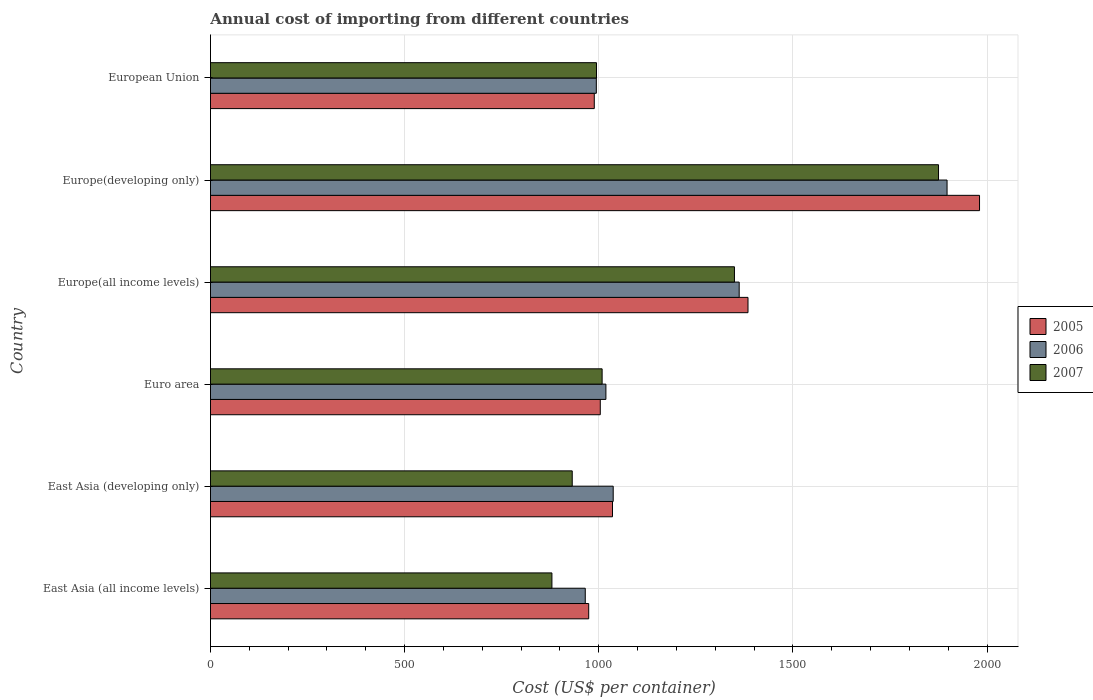Are the number of bars on each tick of the Y-axis equal?
Provide a short and direct response. Yes. How many bars are there on the 1st tick from the top?
Ensure brevity in your answer.  3. What is the label of the 6th group of bars from the top?
Offer a terse response. East Asia (all income levels). What is the total annual cost of importing in 2007 in East Asia (all income levels)?
Provide a succinct answer. 879.32. Across all countries, what is the maximum total annual cost of importing in 2007?
Keep it short and to the point. 1874.94. Across all countries, what is the minimum total annual cost of importing in 2006?
Provide a short and direct response. 965.21. In which country was the total annual cost of importing in 2006 maximum?
Your answer should be compact. Europe(developing only). In which country was the total annual cost of importing in 2007 minimum?
Your answer should be compact. East Asia (all income levels). What is the total total annual cost of importing in 2005 in the graph?
Your answer should be compact. 7366.62. What is the difference between the total annual cost of importing in 2007 in East Asia (developing only) and that in Euro area?
Your answer should be very brief. -77. What is the difference between the total annual cost of importing in 2005 in East Asia (all income levels) and the total annual cost of importing in 2007 in Europe(all income levels)?
Keep it short and to the point. -375.34. What is the average total annual cost of importing in 2006 per country?
Your answer should be compact. 1212.16. What is the difference between the total annual cost of importing in 2007 and total annual cost of importing in 2006 in East Asia (developing only)?
Your answer should be compact. -105.5. In how many countries, is the total annual cost of importing in 2006 greater than 200 US$?
Your response must be concise. 6. What is the ratio of the total annual cost of importing in 2005 in Euro area to that in European Union?
Make the answer very short. 1.02. Is the total annual cost of importing in 2007 in Europe(all income levels) less than that in Europe(developing only)?
Your answer should be compact. Yes. What is the difference between the highest and the second highest total annual cost of importing in 2006?
Your answer should be compact. 535.34. What is the difference between the highest and the lowest total annual cost of importing in 2006?
Make the answer very short. 931.73. Is the sum of the total annual cost of importing in 2006 in East Asia (all income levels) and Euro area greater than the maximum total annual cost of importing in 2007 across all countries?
Offer a very short reply. Yes. What does the 2nd bar from the top in Europe(developing only) represents?
Your response must be concise. 2006. How many bars are there?
Your response must be concise. 18. Does the graph contain any zero values?
Offer a terse response. No. How are the legend labels stacked?
Your response must be concise. Vertical. What is the title of the graph?
Provide a succinct answer. Annual cost of importing from different countries. What is the label or title of the X-axis?
Offer a terse response. Cost (US$ per container). What is the Cost (US$ per container) of 2005 in East Asia (all income levels)?
Ensure brevity in your answer.  974.07. What is the Cost (US$ per container) in 2006 in East Asia (all income levels)?
Offer a terse response. 965.21. What is the Cost (US$ per container) in 2007 in East Asia (all income levels)?
Provide a short and direct response. 879.32. What is the Cost (US$ per container) of 2005 in East Asia (developing only)?
Make the answer very short. 1035.35. What is the Cost (US$ per container) of 2006 in East Asia (developing only)?
Your response must be concise. 1037.15. What is the Cost (US$ per container) in 2007 in East Asia (developing only)?
Keep it short and to the point. 931.65. What is the Cost (US$ per container) of 2005 in Euro area?
Keep it short and to the point. 1003.88. What is the Cost (US$ per container) in 2006 in Euro area?
Offer a terse response. 1018.35. What is the Cost (US$ per container) of 2007 in Euro area?
Ensure brevity in your answer.  1008.65. What is the Cost (US$ per container) of 2005 in Europe(all income levels)?
Your response must be concise. 1384.3. What is the Cost (US$ per container) in 2006 in Europe(all income levels)?
Make the answer very short. 1361.61. What is the Cost (US$ per container) in 2007 in Europe(all income levels)?
Keep it short and to the point. 1349.41. What is the Cost (US$ per container) in 2005 in Europe(developing only)?
Your answer should be very brief. 1980.59. What is the Cost (US$ per container) in 2006 in Europe(developing only)?
Your response must be concise. 1896.94. What is the Cost (US$ per container) of 2007 in Europe(developing only)?
Provide a succinct answer. 1874.94. What is the Cost (US$ per container) in 2005 in European Union?
Provide a short and direct response. 988.44. What is the Cost (US$ per container) in 2006 in European Union?
Provide a succinct answer. 993.69. What is the Cost (US$ per container) of 2007 in European Union?
Offer a very short reply. 994.12. Across all countries, what is the maximum Cost (US$ per container) in 2005?
Your answer should be compact. 1980.59. Across all countries, what is the maximum Cost (US$ per container) in 2006?
Give a very brief answer. 1896.94. Across all countries, what is the maximum Cost (US$ per container) in 2007?
Your response must be concise. 1874.94. Across all countries, what is the minimum Cost (US$ per container) of 2005?
Your response must be concise. 974.07. Across all countries, what is the minimum Cost (US$ per container) in 2006?
Provide a succinct answer. 965.21. Across all countries, what is the minimum Cost (US$ per container) of 2007?
Give a very brief answer. 879.32. What is the total Cost (US$ per container) of 2005 in the graph?
Give a very brief answer. 7366.62. What is the total Cost (US$ per container) in 2006 in the graph?
Give a very brief answer. 7272.96. What is the total Cost (US$ per container) of 2007 in the graph?
Your answer should be very brief. 7038.09. What is the difference between the Cost (US$ per container) of 2005 in East Asia (all income levels) and that in East Asia (developing only)?
Your answer should be very brief. -61.28. What is the difference between the Cost (US$ per container) in 2006 in East Asia (all income levels) and that in East Asia (developing only)?
Your answer should be very brief. -71.94. What is the difference between the Cost (US$ per container) in 2007 in East Asia (all income levels) and that in East Asia (developing only)?
Keep it short and to the point. -52.33. What is the difference between the Cost (US$ per container) in 2005 in East Asia (all income levels) and that in Euro area?
Offer a very short reply. -29.8. What is the difference between the Cost (US$ per container) of 2006 in East Asia (all income levels) and that in Euro area?
Ensure brevity in your answer.  -53.14. What is the difference between the Cost (US$ per container) in 2007 in East Asia (all income levels) and that in Euro area?
Provide a short and direct response. -129.33. What is the difference between the Cost (US$ per container) of 2005 in East Asia (all income levels) and that in Europe(all income levels)?
Your response must be concise. -410.22. What is the difference between the Cost (US$ per container) in 2006 in East Asia (all income levels) and that in Europe(all income levels)?
Your answer should be compact. -396.39. What is the difference between the Cost (US$ per container) of 2007 in East Asia (all income levels) and that in Europe(all income levels)?
Offer a very short reply. -470.09. What is the difference between the Cost (US$ per container) of 2005 in East Asia (all income levels) and that in Europe(developing only)?
Your answer should be very brief. -1006.51. What is the difference between the Cost (US$ per container) of 2006 in East Asia (all income levels) and that in Europe(developing only)?
Your answer should be very brief. -931.73. What is the difference between the Cost (US$ per container) of 2007 in East Asia (all income levels) and that in Europe(developing only)?
Give a very brief answer. -995.62. What is the difference between the Cost (US$ per container) in 2005 in East Asia (all income levels) and that in European Union?
Your answer should be very brief. -14.37. What is the difference between the Cost (US$ per container) in 2006 in East Asia (all income levels) and that in European Union?
Offer a very short reply. -28.48. What is the difference between the Cost (US$ per container) of 2007 in East Asia (all income levels) and that in European Union?
Give a very brief answer. -114.79. What is the difference between the Cost (US$ per container) of 2005 in East Asia (developing only) and that in Euro area?
Provide a succinct answer. 31.48. What is the difference between the Cost (US$ per container) of 2006 in East Asia (developing only) and that in Euro area?
Offer a very short reply. 18.8. What is the difference between the Cost (US$ per container) of 2007 in East Asia (developing only) and that in Euro area?
Ensure brevity in your answer.  -77. What is the difference between the Cost (US$ per container) in 2005 in East Asia (developing only) and that in Europe(all income levels)?
Provide a short and direct response. -348.95. What is the difference between the Cost (US$ per container) in 2006 in East Asia (developing only) and that in Europe(all income levels)?
Give a very brief answer. -324.46. What is the difference between the Cost (US$ per container) of 2007 in East Asia (developing only) and that in Europe(all income levels)?
Make the answer very short. -417.76. What is the difference between the Cost (US$ per container) of 2005 in East Asia (developing only) and that in Europe(developing only)?
Your answer should be compact. -945.24. What is the difference between the Cost (US$ per container) of 2006 in East Asia (developing only) and that in Europe(developing only)?
Make the answer very short. -859.79. What is the difference between the Cost (US$ per container) of 2007 in East Asia (developing only) and that in Europe(developing only)?
Make the answer very short. -943.29. What is the difference between the Cost (US$ per container) of 2005 in East Asia (developing only) and that in European Union?
Keep it short and to the point. 46.91. What is the difference between the Cost (US$ per container) in 2006 in East Asia (developing only) and that in European Union?
Provide a succinct answer. 43.46. What is the difference between the Cost (US$ per container) in 2007 in East Asia (developing only) and that in European Union?
Make the answer very short. -62.47. What is the difference between the Cost (US$ per container) in 2005 in Euro area and that in Europe(all income levels)?
Provide a succinct answer. -380.42. What is the difference between the Cost (US$ per container) of 2006 in Euro area and that in Europe(all income levels)?
Ensure brevity in your answer.  -343.26. What is the difference between the Cost (US$ per container) in 2007 in Euro area and that in Europe(all income levels)?
Provide a short and direct response. -340.77. What is the difference between the Cost (US$ per container) of 2005 in Euro area and that in Europe(developing only)?
Offer a terse response. -976.71. What is the difference between the Cost (US$ per container) in 2006 in Euro area and that in Europe(developing only)?
Give a very brief answer. -878.59. What is the difference between the Cost (US$ per container) of 2007 in Euro area and that in Europe(developing only)?
Offer a very short reply. -866.3. What is the difference between the Cost (US$ per container) in 2005 in Euro area and that in European Union?
Ensure brevity in your answer.  15.44. What is the difference between the Cost (US$ per container) in 2006 in Euro area and that in European Union?
Your answer should be compact. 24.66. What is the difference between the Cost (US$ per container) of 2007 in Euro area and that in European Union?
Provide a succinct answer. 14.53. What is the difference between the Cost (US$ per container) in 2005 in Europe(all income levels) and that in Europe(developing only)?
Offer a very short reply. -596.29. What is the difference between the Cost (US$ per container) of 2006 in Europe(all income levels) and that in Europe(developing only)?
Make the answer very short. -535.34. What is the difference between the Cost (US$ per container) in 2007 in Europe(all income levels) and that in Europe(developing only)?
Offer a terse response. -525.53. What is the difference between the Cost (US$ per container) in 2005 in Europe(all income levels) and that in European Union?
Provide a short and direct response. 395.86. What is the difference between the Cost (US$ per container) in 2006 in Europe(all income levels) and that in European Union?
Offer a very short reply. 367.92. What is the difference between the Cost (US$ per container) of 2007 in Europe(all income levels) and that in European Union?
Make the answer very short. 355.3. What is the difference between the Cost (US$ per container) in 2005 in Europe(developing only) and that in European Union?
Offer a very short reply. 992.15. What is the difference between the Cost (US$ per container) in 2006 in Europe(developing only) and that in European Union?
Ensure brevity in your answer.  903.25. What is the difference between the Cost (US$ per container) in 2007 in Europe(developing only) and that in European Union?
Offer a very short reply. 880.83. What is the difference between the Cost (US$ per container) of 2005 in East Asia (all income levels) and the Cost (US$ per container) of 2006 in East Asia (developing only)?
Keep it short and to the point. -63.08. What is the difference between the Cost (US$ per container) in 2005 in East Asia (all income levels) and the Cost (US$ per container) in 2007 in East Asia (developing only)?
Offer a very short reply. 42.42. What is the difference between the Cost (US$ per container) of 2006 in East Asia (all income levels) and the Cost (US$ per container) of 2007 in East Asia (developing only)?
Give a very brief answer. 33.56. What is the difference between the Cost (US$ per container) of 2005 in East Asia (all income levels) and the Cost (US$ per container) of 2006 in Euro area?
Give a very brief answer. -44.28. What is the difference between the Cost (US$ per container) in 2005 in East Asia (all income levels) and the Cost (US$ per container) in 2007 in Euro area?
Your answer should be very brief. -34.57. What is the difference between the Cost (US$ per container) in 2006 in East Asia (all income levels) and the Cost (US$ per container) in 2007 in Euro area?
Offer a very short reply. -43.43. What is the difference between the Cost (US$ per container) of 2005 in East Asia (all income levels) and the Cost (US$ per container) of 2006 in Europe(all income levels)?
Offer a very short reply. -387.53. What is the difference between the Cost (US$ per container) of 2005 in East Asia (all income levels) and the Cost (US$ per container) of 2007 in Europe(all income levels)?
Your answer should be compact. -375.34. What is the difference between the Cost (US$ per container) in 2006 in East Asia (all income levels) and the Cost (US$ per container) in 2007 in Europe(all income levels)?
Make the answer very short. -384.2. What is the difference between the Cost (US$ per container) in 2005 in East Asia (all income levels) and the Cost (US$ per container) in 2006 in Europe(developing only)?
Ensure brevity in your answer.  -922.87. What is the difference between the Cost (US$ per container) of 2005 in East Asia (all income levels) and the Cost (US$ per container) of 2007 in Europe(developing only)?
Provide a succinct answer. -900.87. What is the difference between the Cost (US$ per container) in 2006 in East Asia (all income levels) and the Cost (US$ per container) in 2007 in Europe(developing only)?
Offer a terse response. -909.73. What is the difference between the Cost (US$ per container) of 2005 in East Asia (all income levels) and the Cost (US$ per container) of 2006 in European Union?
Offer a very short reply. -19.62. What is the difference between the Cost (US$ per container) in 2005 in East Asia (all income levels) and the Cost (US$ per container) in 2007 in European Union?
Your response must be concise. -20.04. What is the difference between the Cost (US$ per container) of 2006 in East Asia (all income levels) and the Cost (US$ per container) of 2007 in European Union?
Give a very brief answer. -28.9. What is the difference between the Cost (US$ per container) of 2005 in East Asia (developing only) and the Cost (US$ per container) of 2006 in Euro area?
Provide a succinct answer. 17. What is the difference between the Cost (US$ per container) of 2005 in East Asia (developing only) and the Cost (US$ per container) of 2007 in Euro area?
Provide a succinct answer. 26.7. What is the difference between the Cost (US$ per container) of 2006 in East Asia (developing only) and the Cost (US$ per container) of 2007 in Euro area?
Make the answer very short. 28.5. What is the difference between the Cost (US$ per container) in 2005 in East Asia (developing only) and the Cost (US$ per container) in 2006 in Europe(all income levels)?
Make the answer very short. -326.26. What is the difference between the Cost (US$ per container) in 2005 in East Asia (developing only) and the Cost (US$ per container) in 2007 in Europe(all income levels)?
Keep it short and to the point. -314.06. What is the difference between the Cost (US$ per container) in 2006 in East Asia (developing only) and the Cost (US$ per container) in 2007 in Europe(all income levels)?
Ensure brevity in your answer.  -312.26. What is the difference between the Cost (US$ per container) of 2005 in East Asia (developing only) and the Cost (US$ per container) of 2006 in Europe(developing only)?
Ensure brevity in your answer.  -861.59. What is the difference between the Cost (US$ per container) in 2005 in East Asia (developing only) and the Cost (US$ per container) in 2007 in Europe(developing only)?
Your answer should be compact. -839.59. What is the difference between the Cost (US$ per container) of 2006 in East Asia (developing only) and the Cost (US$ per container) of 2007 in Europe(developing only)?
Your response must be concise. -837.79. What is the difference between the Cost (US$ per container) in 2005 in East Asia (developing only) and the Cost (US$ per container) in 2006 in European Union?
Offer a very short reply. 41.66. What is the difference between the Cost (US$ per container) in 2005 in East Asia (developing only) and the Cost (US$ per container) in 2007 in European Union?
Provide a short and direct response. 41.23. What is the difference between the Cost (US$ per container) of 2006 in East Asia (developing only) and the Cost (US$ per container) of 2007 in European Union?
Ensure brevity in your answer.  43.03. What is the difference between the Cost (US$ per container) of 2005 in Euro area and the Cost (US$ per container) of 2006 in Europe(all income levels)?
Ensure brevity in your answer.  -357.73. What is the difference between the Cost (US$ per container) of 2005 in Euro area and the Cost (US$ per container) of 2007 in Europe(all income levels)?
Offer a very short reply. -345.54. What is the difference between the Cost (US$ per container) in 2006 in Euro area and the Cost (US$ per container) in 2007 in Europe(all income levels)?
Keep it short and to the point. -331.06. What is the difference between the Cost (US$ per container) in 2005 in Euro area and the Cost (US$ per container) in 2006 in Europe(developing only)?
Offer a very short reply. -893.07. What is the difference between the Cost (US$ per container) of 2005 in Euro area and the Cost (US$ per container) of 2007 in Europe(developing only)?
Your answer should be very brief. -871.07. What is the difference between the Cost (US$ per container) in 2006 in Euro area and the Cost (US$ per container) in 2007 in Europe(developing only)?
Ensure brevity in your answer.  -856.59. What is the difference between the Cost (US$ per container) of 2005 in Euro area and the Cost (US$ per container) of 2006 in European Union?
Give a very brief answer. 10.18. What is the difference between the Cost (US$ per container) in 2005 in Euro area and the Cost (US$ per container) in 2007 in European Union?
Ensure brevity in your answer.  9.76. What is the difference between the Cost (US$ per container) in 2006 in Euro area and the Cost (US$ per container) in 2007 in European Union?
Offer a terse response. 24.24. What is the difference between the Cost (US$ per container) in 2005 in Europe(all income levels) and the Cost (US$ per container) in 2006 in Europe(developing only)?
Keep it short and to the point. -512.65. What is the difference between the Cost (US$ per container) in 2005 in Europe(all income levels) and the Cost (US$ per container) in 2007 in Europe(developing only)?
Provide a short and direct response. -490.65. What is the difference between the Cost (US$ per container) in 2006 in Europe(all income levels) and the Cost (US$ per container) in 2007 in Europe(developing only)?
Keep it short and to the point. -513.34. What is the difference between the Cost (US$ per container) in 2005 in Europe(all income levels) and the Cost (US$ per container) in 2006 in European Union?
Provide a short and direct response. 390.6. What is the difference between the Cost (US$ per container) of 2005 in Europe(all income levels) and the Cost (US$ per container) of 2007 in European Union?
Provide a short and direct response. 390.18. What is the difference between the Cost (US$ per container) of 2006 in Europe(all income levels) and the Cost (US$ per container) of 2007 in European Union?
Your answer should be compact. 367.49. What is the difference between the Cost (US$ per container) in 2005 in Europe(developing only) and the Cost (US$ per container) in 2006 in European Union?
Your answer should be very brief. 986.9. What is the difference between the Cost (US$ per container) of 2005 in Europe(developing only) and the Cost (US$ per container) of 2007 in European Union?
Keep it short and to the point. 986.47. What is the difference between the Cost (US$ per container) of 2006 in Europe(developing only) and the Cost (US$ per container) of 2007 in European Union?
Your answer should be compact. 902.83. What is the average Cost (US$ per container) of 2005 per country?
Offer a very short reply. 1227.77. What is the average Cost (US$ per container) of 2006 per country?
Your answer should be compact. 1212.16. What is the average Cost (US$ per container) in 2007 per country?
Make the answer very short. 1173.02. What is the difference between the Cost (US$ per container) in 2005 and Cost (US$ per container) in 2006 in East Asia (all income levels)?
Keep it short and to the point. 8.86. What is the difference between the Cost (US$ per container) of 2005 and Cost (US$ per container) of 2007 in East Asia (all income levels)?
Your response must be concise. 94.75. What is the difference between the Cost (US$ per container) in 2006 and Cost (US$ per container) in 2007 in East Asia (all income levels)?
Your answer should be compact. 85.89. What is the difference between the Cost (US$ per container) of 2005 and Cost (US$ per container) of 2007 in East Asia (developing only)?
Your answer should be very brief. 103.7. What is the difference between the Cost (US$ per container) of 2006 and Cost (US$ per container) of 2007 in East Asia (developing only)?
Ensure brevity in your answer.  105.5. What is the difference between the Cost (US$ per container) of 2005 and Cost (US$ per container) of 2006 in Euro area?
Provide a succinct answer. -14.48. What is the difference between the Cost (US$ per container) of 2005 and Cost (US$ per container) of 2007 in Euro area?
Your response must be concise. -4.77. What is the difference between the Cost (US$ per container) in 2006 and Cost (US$ per container) in 2007 in Euro area?
Provide a short and direct response. 9.71. What is the difference between the Cost (US$ per container) of 2005 and Cost (US$ per container) of 2006 in Europe(all income levels)?
Your answer should be very brief. 22.69. What is the difference between the Cost (US$ per container) of 2005 and Cost (US$ per container) of 2007 in Europe(all income levels)?
Keep it short and to the point. 34.88. What is the difference between the Cost (US$ per container) in 2006 and Cost (US$ per container) in 2007 in Europe(all income levels)?
Make the answer very short. 12.2. What is the difference between the Cost (US$ per container) in 2005 and Cost (US$ per container) in 2006 in Europe(developing only)?
Your answer should be compact. 83.64. What is the difference between the Cost (US$ per container) in 2005 and Cost (US$ per container) in 2007 in Europe(developing only)?
Make the answer very short. 105.64. What is the difference between the Cost (US$ per container) in 2006 and Cost (US$ per container) in 2007 in Europe(developing only)?
Keep it short and to the point. 22. What is the difference between the Cost (US$ per container) of 2005 and Cost (US$ per container) of 2006 in European Union?
Ensure brevity in your answer.  -5.25. What is the difference between the Cost (US$ per container) in 2005 and Cost (US$ per container) in 2007 in European Union?
Make the answer very short. -5.68. What is the difference between the Cost (US$ per container) in 2006 and Cost (US$ per container) in 2007 in European Union?
Make the answer very short. -0.42. What is the ratio of the Cost (US$ per container) in 2005 in East Asia (all income levels) to that in East Asia (developing only)?
Provide a short and direct response. 0.94. What is the ratio of the Cost (US$ per container) in 2006 in East Asia (all income levels) to that in East Asia (developing only)?
Offer a very short reply. 0.93. What is the ratio of the Cost (US$ per container) of 2007 in East Asia (all income levels) to that in East Asia (developing only)?
Keep it short and to the point. 0.94. What is the ratio of the Cost (US$ per container) in 2005 in East Asia (all income levels) to that in Euro area?
Your response must be concise. 0.97. What is the ratio of the Cost (US$ per container) of 2006 in East Asia (all income levels) to that in Euro area?
Provide a succinct answer. 0.95. What is the ratio of the Cost (US$ per container) of 2007 in East Asia (all income levels) to that in Euro area?
Provide a succinct answer. 0.87. What is the ratio of the Cost (US$ per container) of 2005 in East Asia (all income levels) to that in Europe(all income levels)?
Give a very brief answer. 0.7. What is the ratio of the Cost (US$ per container) in 2006 in East Asia (all income levels) to that in Europe(all income levels)?
Your answer should be very brief. 0.71. What is the ratio of the Cost (US$ per container) of 2007 in East Asia (all income levels) to that in Europe(all income levels)?
Give a very brief answer. 0.65. What is the ratio of the Cost (US$ per container) of 2005 in East Asia (all income levels) to that in Europe(developing only)?
Your response must be concise. 0.49. What is the ratio of the Cost (US$ per container) of 2006 in East Asia (all income levels) to that in Europe(developing only)?
Provide a succinct answer. 0.51. What is the ratio of the Cost (US$ per container) in 2007 in East Asia (all income levels) to that in Europe(developing only)?
Provide a succinct answer. 0.47. What is the ratio of the Cost (US$ per container) in 2005 in East Asia (all income levels) to that in European Union?
Keep it short and to the point. 0.99. What is the ratio of the Cost (US$ per container) in 2006 in East Asia (all income levels) to that in European Union?
Keep it short and to the point. 0.97. What is the ratio of the Cost (US$ per container) in 2007 in East Asia (all income levels) to that in European Union?
Make the answer very short. 0.88. What is the ratio of the Cost (US$ per container) of 2005 in East Asia (developing only) to that in Euro area?
Give a very brief answer. 1.03. What is the ratio of the Cost (US$ per container) of 2006 in East Asia (developing only) to that in Euro area?
Provide a short and direct response. 1.02. What is the ratio of the Cost (US$ per container) in 2007 in East Asia (developing only) to that in Euro area?
Make the answer very short. 0.92. What is the ratio of the Cost (US$ per container) in 2005 in East Asia (developing only) to that in Europe(all income levels)?
Provide a succinct answer. 0.75. What is the ratio of the Cost (US$ per container) in 2006 in East Asia (developing only) to that in Europe(all income levels)?
Provide a succinct answer. 0.76. What is the ratio of the Cost (US$ per container) of 2007 in East Asia (developing only) to that in Europe(all income levels)?
Keep it short and to the point. 0.69. What is the ratio of the Cost (US$ per container) of 2005 in East Asia (developing only) to that in Europe(developing only)?
Provide a succinct answer. 0.52. What is the ratio of the Cost (US$ per container) of 2006 in East Asia (developing only) to that in Europe(developing only)?
Your answer should be compact. 0.55. What is the ratio of the Cost (US$ per container) of 2007 in East Asia (developing only) to that in Europe(developing only)?
Your answer should be compact. 0.5. What is the ratio of the Cost (US$ per container) in 2005 in East Asia (developing only) to that in European Union?
Offer a terse response. 1.05. What is the ratio of the Cost (US$ per container) in 2006 in East Asia (developing only) to that in European Union?
Give a very brief answer. 1.04. What is the ratio of the Cost (US$ per container) of 2007 in East Asia (developing only) to that in European Union?
Offer a terse response. 0.94. What is the ratio of the Cost (US$ per container) in 2005 in Euro area to that in Europe(all income levels)?
Your response must be concise. 0.73. What is the ratio of the Cost (US$ per container) of 2006 in Euro area to that in Europe(all income levels)?
Provide a short and direct response. 0.75. What is the ratio of the Cost (US$ per container) in 2007 in Euro area to that in Europe(all income levels)?
Ensure brevity in your answer.  0.75. What is the ratio of the Cost (US$ per container) of 2005 in Euro area to that in Europe(developing only)?
Keep it short and to the point. 0.51. What is the ratio of the Cost (US$ per container) of 2006 in Euro area to that in Europe(developing only)?
Offer a very short reply. 0.54. What is the ratio of the Cost (US$ per container) of 2007 in Euro area to that in Europe(developing only)?
Offer a terse response. 0.54. What is the ratio of the Cost (US$ per container) of 2005 in Euro area to that in European Union?
Your answer should be compact. 1.02. What is the ratio of the Cost (US$ per container) of 2006 in Euro area to that in European Union?
Keep it short and to the point. 1.02. What is the ratio of the Cost (US$ per container) of 2007 in Euro area to that in European Union?
Make the answer very short. 1.01. What is the ratio of the Cost (US$ per container) in 2005 in Europe(all income levels) to that in Europe(developing only)?
Your response must be concise. 0.7. What is the ratio of the Cost (US$ per container) in 2006 in Europe(all income levels) to that in Europe(developing only)?
Provide a succinct answer. 0.72. What is the ratio of the Cost (US$ per container) in 2007 in Europe(all income levels) to that in Europe(developing only)?
Your answer should be very brief. 0.72. What is the ratio of the Cost (US$ per container) in 2005 in Europe(all income levels) to that in European Union?
Your answer should be very brief. 1.4. What is the ratio of the Cost (US$ per container) of 2006 in Europe(all income levels) to that in European Union?
Your response must be concise. 1.37. What is the ratio of the Cost (US$ per container) in 2007 in Europe(all income levels) to that in European Union?
Provide a succinct answer. 1.36. What is the ratio of the Cost (US$ per container) of 2005 in Europe(developing only) to that in European Union?
Your answer should be compact. 2. What is the ratio of the Cost (US$ per container) in 2006 in Europe(developing only) to that in European Union?
Offer a very short reply. 1.91. What is the ratio of the Cost (US$ per container) in 2007 in Europe(developing only) to that in European Union?
Ensure brevity in your answer.  1.89. What is the difference between the highest and the second highest Cost (US$ per container) in 2005?
Offer a terse response. 596.29. What is the difference between the highest and the second highest Cost (US$ per container) of 2006?
Offer a very short reply. 535.34. What is the difference between the highest and the second highest Cost (US$ per container) of 2007?
Your response must be concise. 525.53. What is the difference between the highest and the lowest Cost (US$ per container) in 2005?
Provide a short and direct response. 1006.51. What is the difference between the highest and the lowest Cost (US$ per container) of 2006?
Ensure brevity in your answer.  931.73. What is the difference between the highest and the lowest Cost (US$ per container) of 2007?
Your answer should be compact. 995.62. 